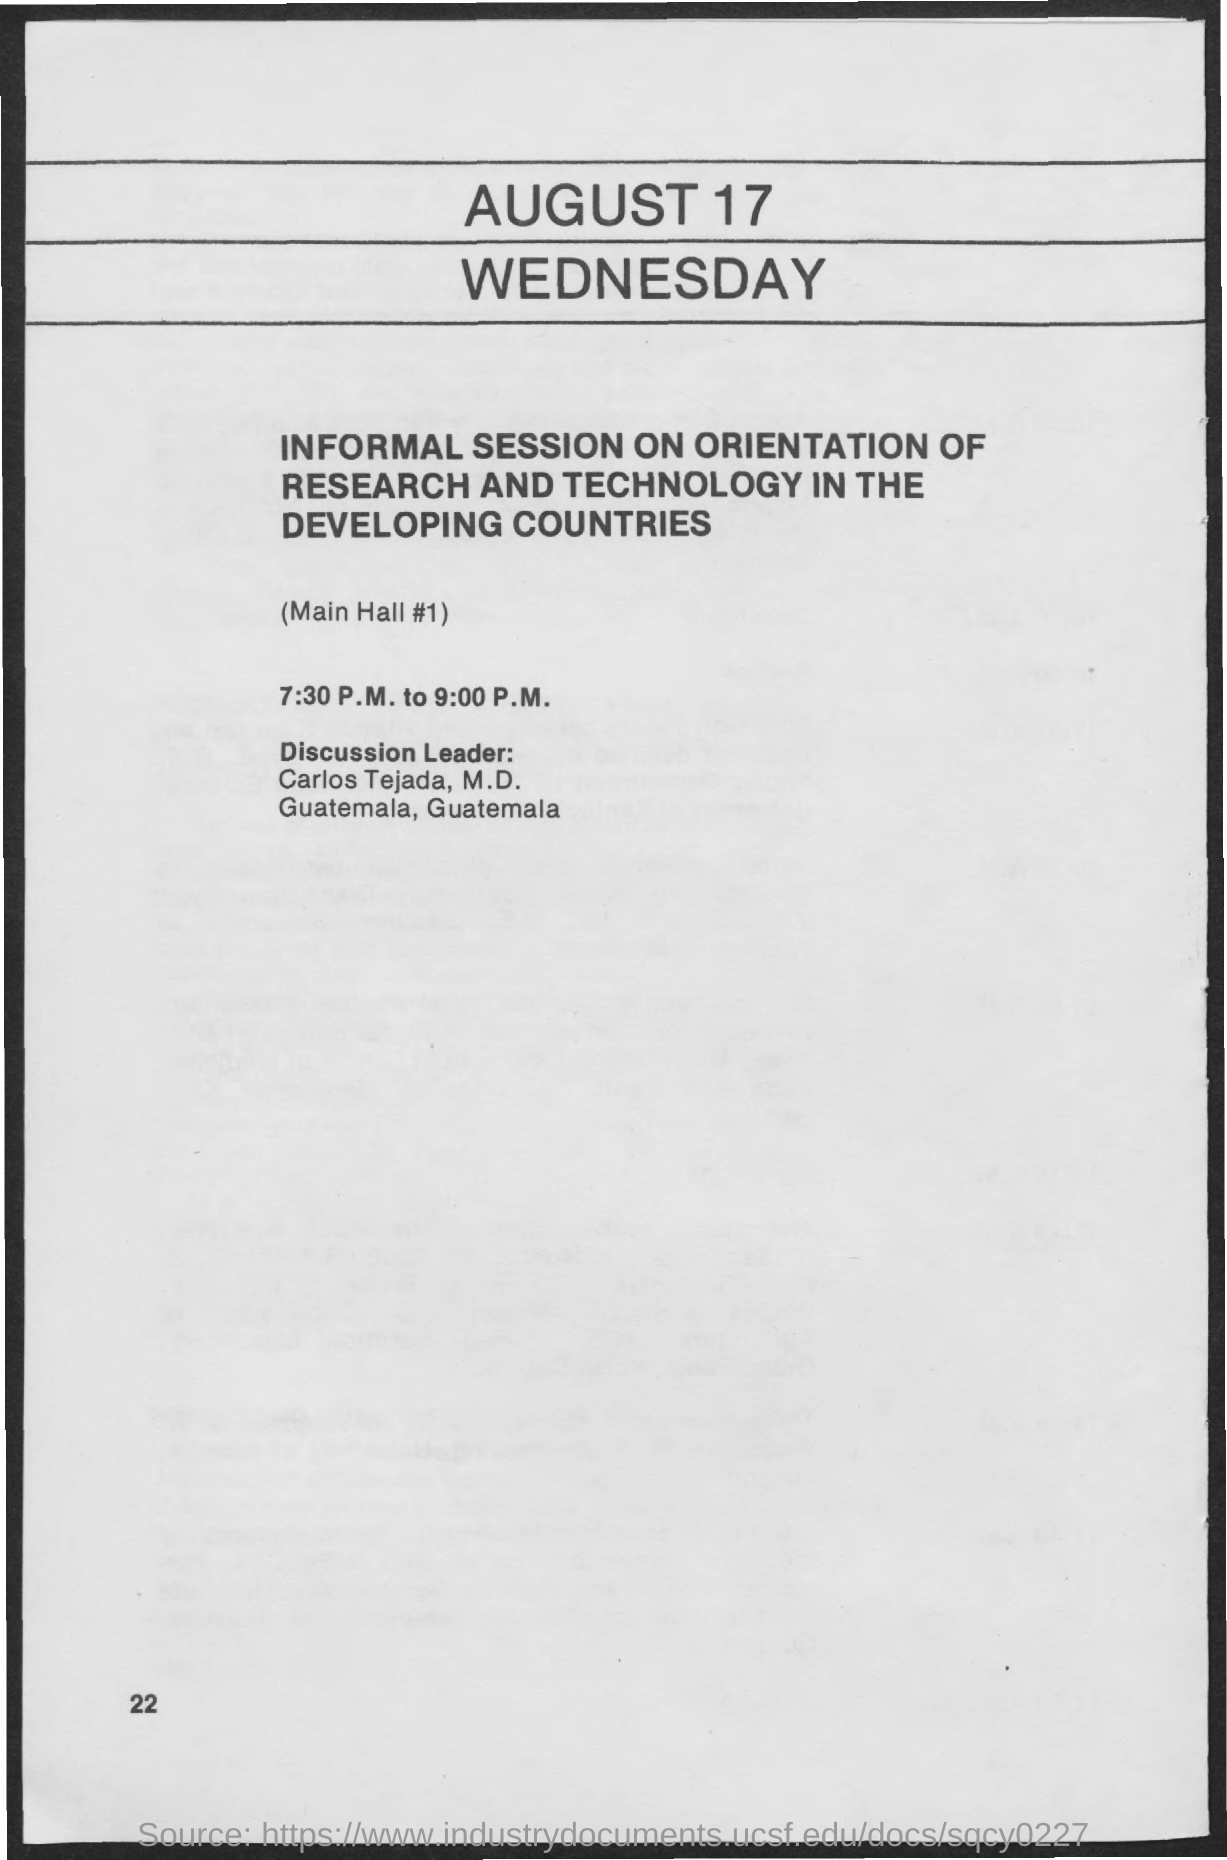What is the date on the document?
Provide a succinct answer. August 17. What is the time for the informal session?
Provide a succinct answer. 7:30 P.M. to 9:00 P.M. 